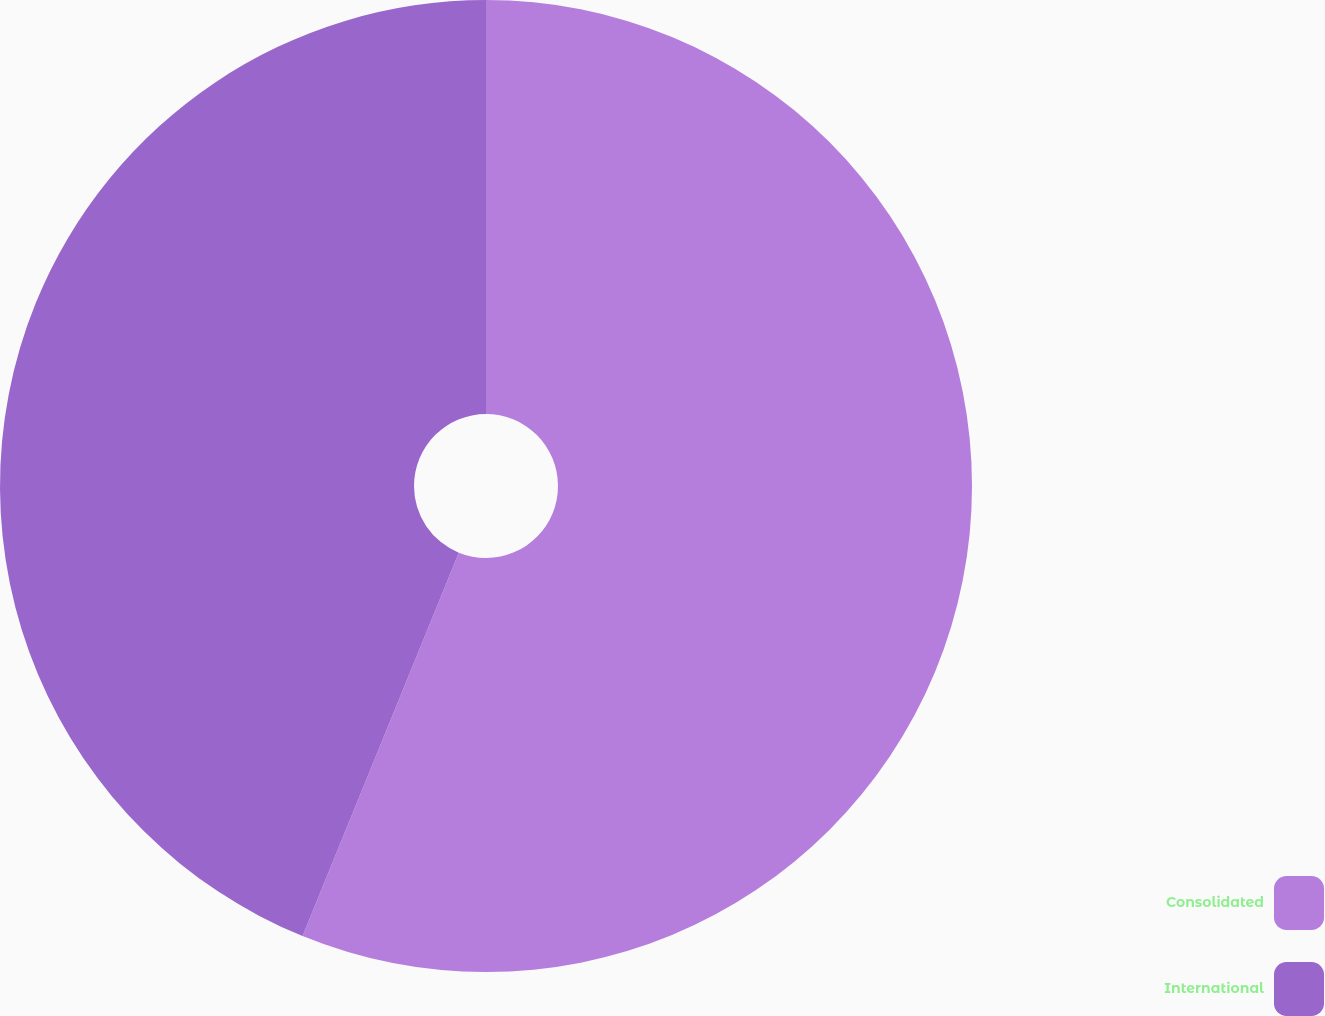<chart> <loc_0><loc_0><loc_500><loc_500><pie_chart><fcel>Consolidated<fcel>International<nl><fcel>56.16%<fcel>43.84%<nl></chart> 